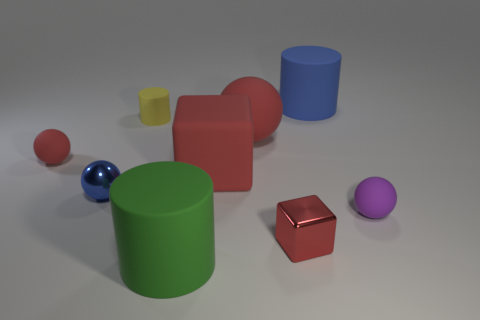There is a purple object that is the same shape as the tiny blue metal thing; what is its size?
Ensure brevity in your answer.  Small. There is a yellow matte thing; is it the same size as the sphere that is on the right side of the small shiny block?
Provide a short and direct response. Yes. Is there a large matte cube that is on the left side of the big matte cylinder left of the large blue matte cylinder?
Your answer should be very brief. No. What shape is the big object in front of the blue shiny ball?
Offer a terse response. Cylinder. What material is the large sphere that is the same color as the rubber block?
Your answer should be compact. Rubber. What color is the matte cylinder in front of the red rubber sphere on the left side of the yellow cylinder?
Offer a very short reply. Green. Does the rubber block have the same size as the green cylinder?
Offer a terse response. Yes. What is the material of the big thing that is the same shape as the tiny purple matte thing?
Your answer should be very brief. Rubber. How many red matte cylinders are the same size as the purple sphere?
Keep it short and to the point. 0. What is the color of the other big ball that is made of the same material as the purple sphere?
Make the answer very short. Red. 